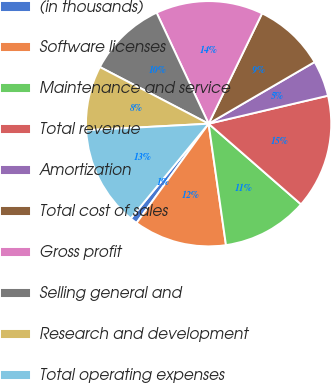<chart> <loc_0><loc_0><loc_500><loc_500><pie_chart><fcel>(in thousands)<fcel>Software licenses<fcel>Maintenance and service<fcel>Total revenue<fcel>Amortization<fcel>Total cost of sales<fcel>Gross profit<fcel>Selling general and<fcel>Research and development<fcel>Total operating expenses<nl><fcel>0.95%<fcel>12.26%<fcel>11.32%<fcel>15.09%<fcel>4.72%<fcel>9.43%<fcel>14.15%<fcel>10.38%<fcel>8.49%<fcel>13.21%<nl></chart> 